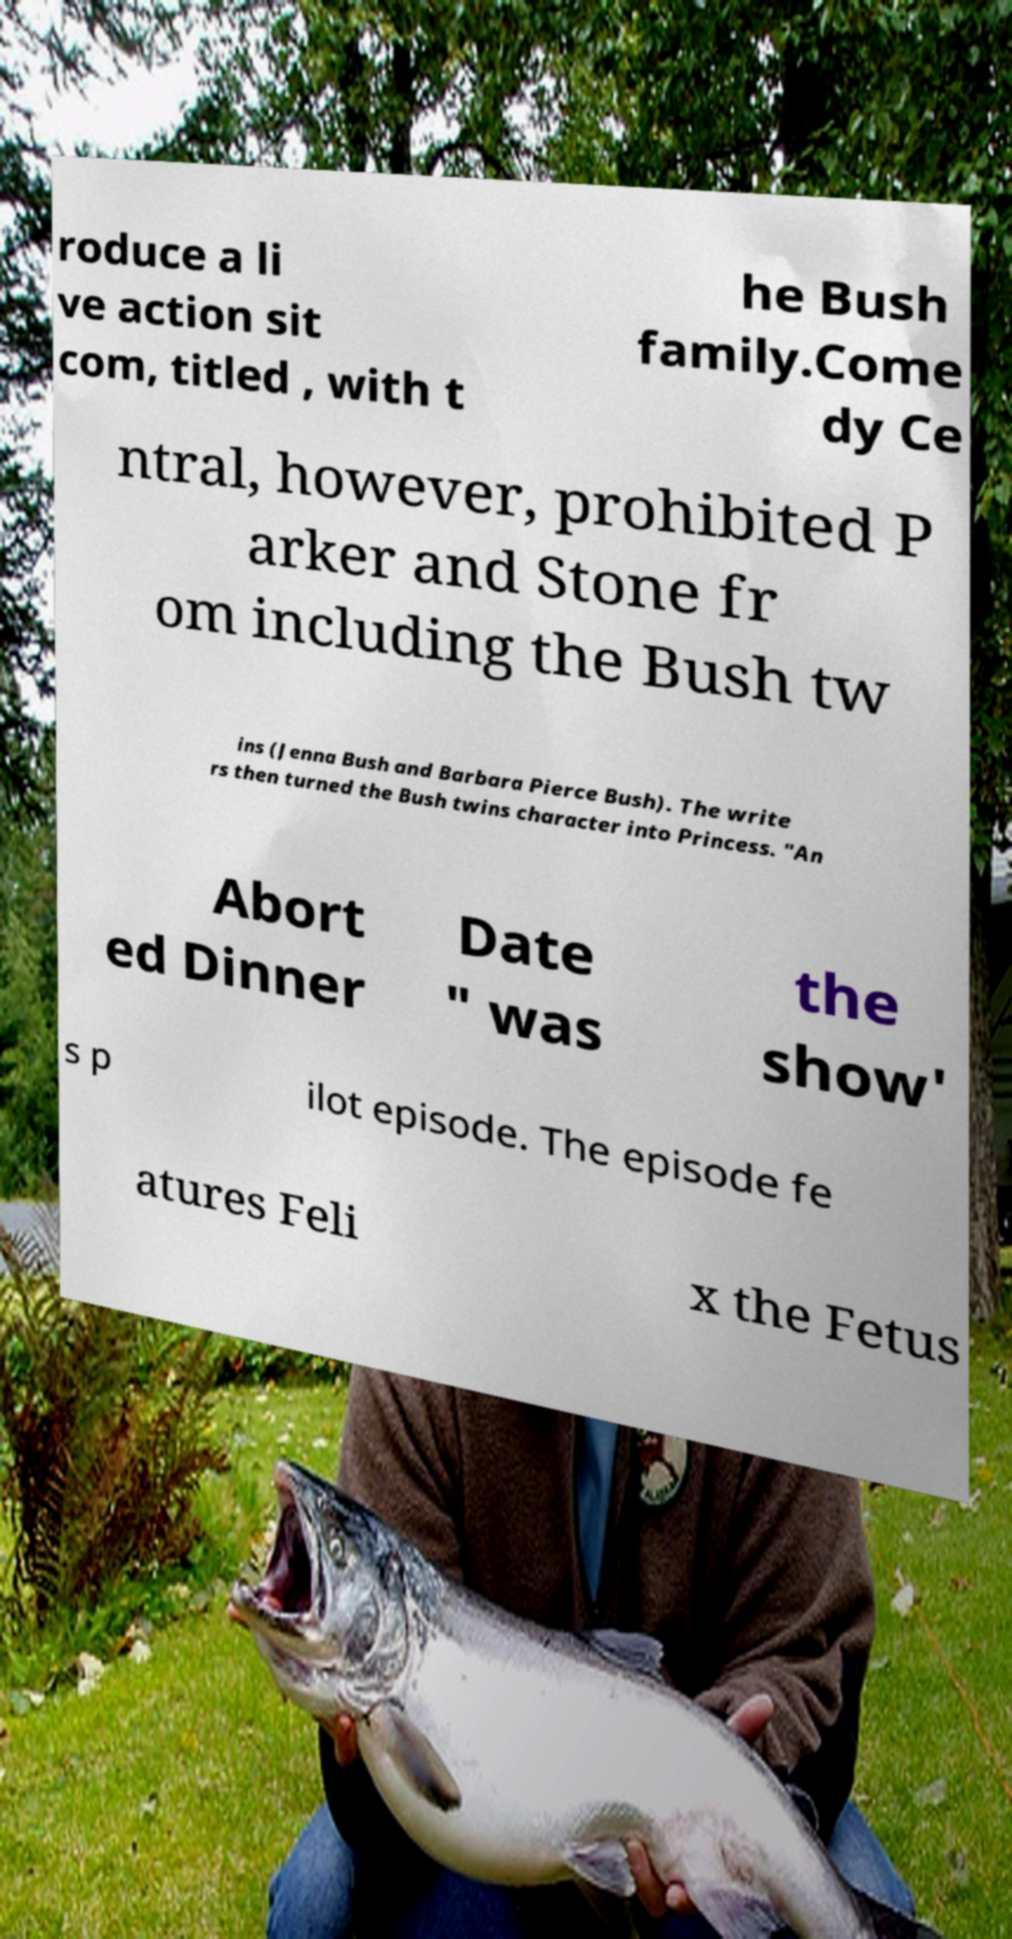There's text embedded in this image that I need extracted. Can you transcribe it verbatim? roduce a li ve action sit com, titled , with t he Bush family.Come dy Ce ntral, however, prohibited P arker and Stone fr om including the Bush tw ins (Jenna Bush and Barbara Pierce Bush). The write rs then turned the Bush twins character into Princess. "An Abort ed Dinner Date " was the show' s p ilot episode. The episode fe atures Feli x the Fetus 